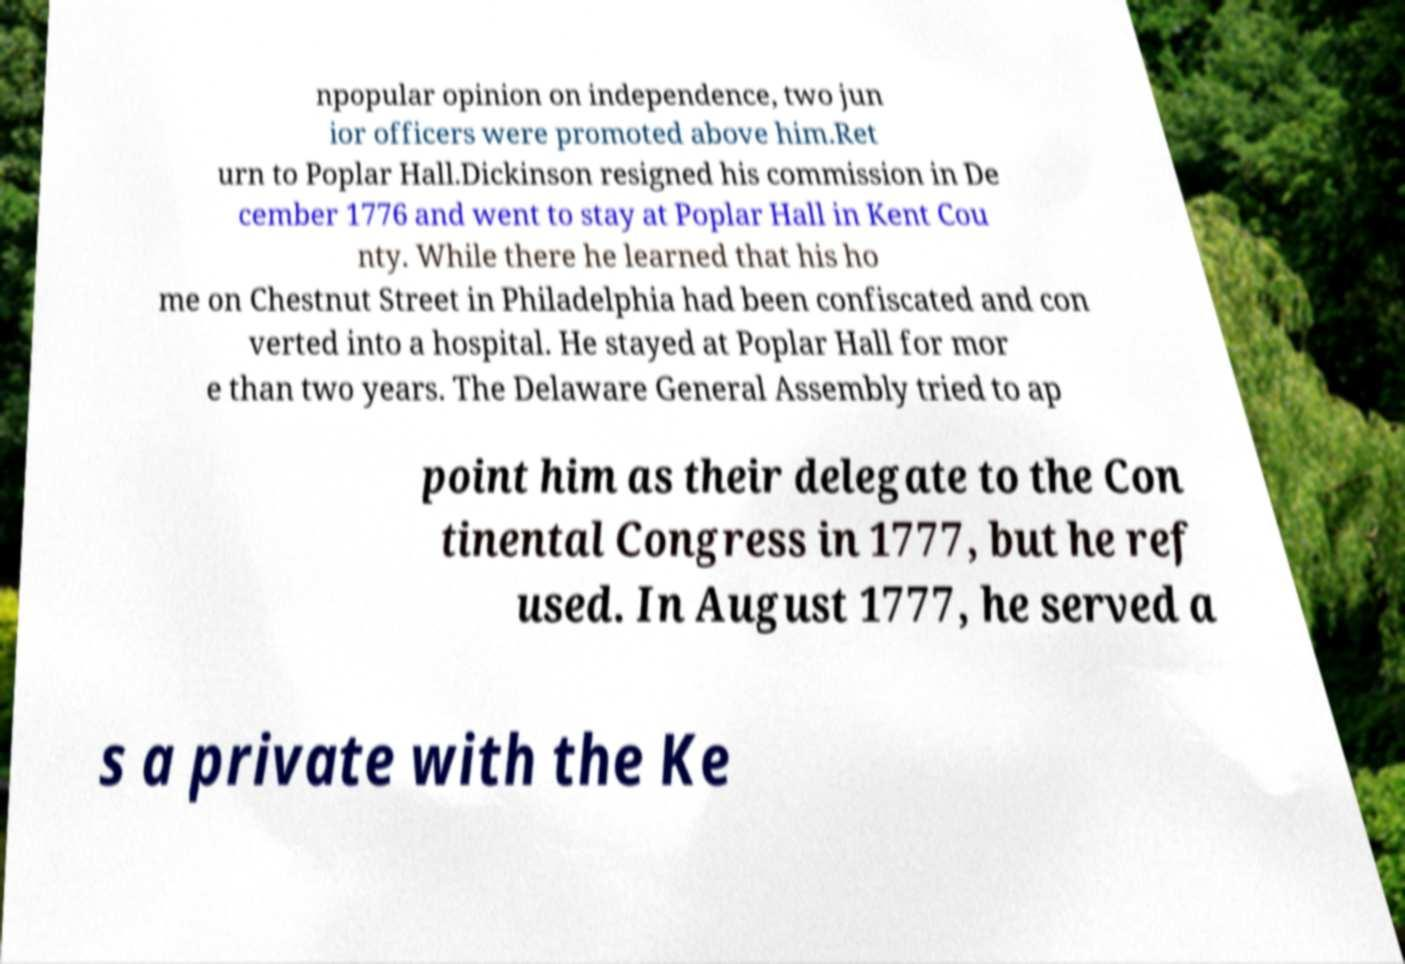I need the written content from this picture converted into text. Can you do that? npopular opinion on independence, two jun ior officers were promoted above him.Ret urn to Poplar Hall.Dickinson resigned his commission in De cember 1776 and went to stay at Poplar Hall in Kent Cou nty. While there he learned that his ho me on Chestnut Street in Philadelphia had been confiscated and con verted into a hospital. He stayed at Poplar Hall for mor e than two years. The Delaware General Assembly tried to ap point him as their delegate to the Con tinental Congress in 1777, but he ref used. In August 1777, he served a s a private with the Ke 